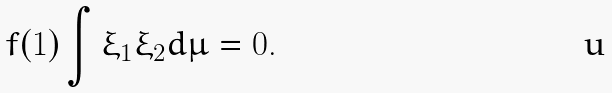Convert formula to latex. <formula><loc_0><loc_0><loc_500><loc_500>f ( 1 ) \int \xi _ { 1 } \xi _ { 2 } d \mu = 0 .</formula> 